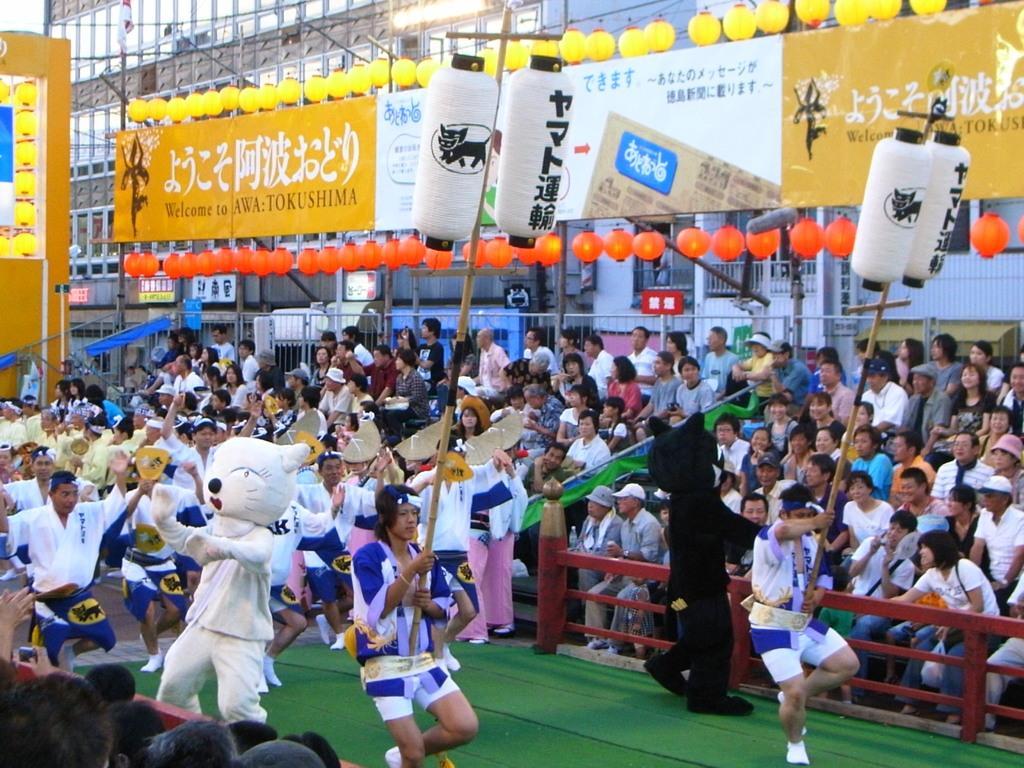Please provide a concise description of this image. These people are in motion and these two people holding sticks. These people are wore costumes and these people are audience. In the background we can see hoarding,balloons,buildings,poles,fence and boards. 